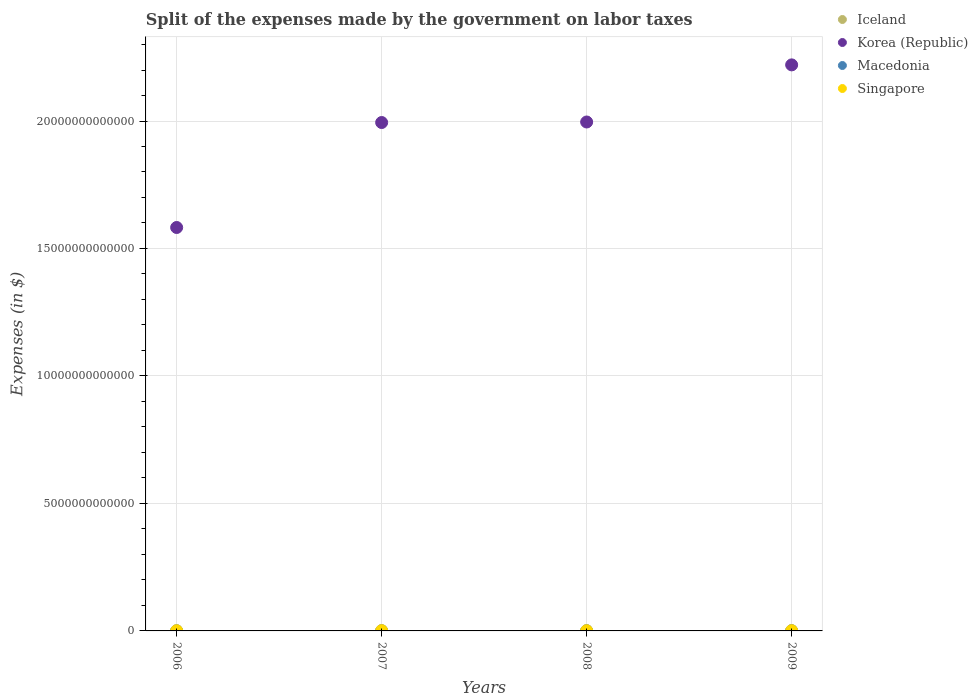How many different coloured dotlines are there?
Provide a succinct answer. 4. What is the expenses made by the government on labor taxes in Macedonia in 2006?
Ensure brevity in your answer.  6.58e+06. Across all years, what is the maximum expenses made by the government on labor taxes in Singapore?
Provide a succinct answer. 7.79e+09. Across all years, what is the minimum expenses made by the government on labor taxes in Singapore?
Provide a succinct answer. 5.35e+09. In which year was the expenses made by the government on labor taxes in Korea (Republic) minimum?
Your answer should be compact. 2006. What is the total expenses made by the government on labor taxes in Iceland in the graph?
Offer a terse response. 4.62e+1. What is the difference between the expenses made by the government on labor taxes in Iceland in 2006 and that in 2008?
Make the answer very short. -9.48e+08. What is the difference between the expenses made by the government on labor taxes in Macedonia in 2006 and the expenses made by the government on labor taxes in Singapore in 2007?
Offer a very short reply. -7.78e+09. What is the average expenses made by the government on labor taxes in Macedonia per year?
Give a very brief answer. 1.31e+09. In the year 2006, what is the difference between the expenses made by the government on labor taxes in Singapore and expenses made by the government on labor taxes in Korea (Republic)?
Ensure brevity in your answer.  -1.58e+13. What is the ratio of the expenses made by the government on labor taxes in Iceland in 2008 to that in 2009?
Your answer should be very brief. 0.86. Is the expenses made by the government on labor taxes in Singapore in 2008 less than that in 2009?
Provide a short and direct response. Yes. Is the difference between the expenses made by the government on labor taxes in Singapore in 2006 and 2009 greater than the difference between the expenses made by the government on labor taxes in Korea (Republic) in 2006 and 2009?
Offer a terse response. Yes. What is the difference between the highest and the second highest expenses made by the government on labor taxes in Macedonia?
Your answer should be compact. 1.15e+08. What is the difference between the highest and the lowest expenses made by the government on labor taxes in Iceland?
Your answer should be very brief. 3.82e+09. In how many years, is the expenses made by the government on labor taxes in Singapore greater than the average expenses made by the government on labor taxes in Singapore taken over all years?
Offer a very short reply. 2. Is the sum of the expenses made by the government on labor taxes in Iceland in 2007 and 2008 greater than the maximum expenses made by the government on labor taxes in Singapore across all years?
Your response must be concise. Yes. Is it the case that in every year, the sum of the expenses made by the government on labor taxes in Korea (Republic) and expenses made by the government on labor taxes in Iceland  is greater than the sum of expenses made by the government on labor taxes in Singapore and expenses made by the government on labor taxes in Macedonia?
Your response must be concise. No. Is it the case that in every year, the sum of the expenses made by the government on labor taxes in Korea (Republic) and expenses made by the government on labor taxes in Macedonia  is greater than the expenses made by the government on labor taxes in Singapore?
Ensure brevity in your answer.  Yes. Does the expenses made by the government on labor taxes in Macedonia monotonically increase over the years?
Offer a very short reply. Yes. Is the expenses made by the government on labor taxes in Iceland strictly less than the expenses made by the government on labor taxes in Korea (Republic) over the years?
Ensure brevity in your answer.  Yes. How many dotlines are there?
Offer a very short reply. 4. What is the difference between two consecutive major ticks on the Y-axis?
Your response must be concise. 5.00e+12. Are the values on the major ticks of Y-axis written in scientific E-notation?
Offer a terse response. No. Where does the legend appear in the graph?
Your answer should be very brief. Top right. How are the legend labels stacked?
Give a very brief answer. Vertical. What is the title of the graph?
Your answer should be very brief. Split of the expenses made by the government on labor taxes. Does "World" appear as one of the legend labels in the graph?
Your response must be concise. No. What is the label or title of the X-axis?
Provide a short and direct response. Years. What is the label or title of the Y-axis?
Ensure brevity in your answer.  Expenses (in $). What is the Expenses (in $) of Iceland in 2006?
Offer a terse response. 9.70e+09. What is the Expenses (in $) in Korea (Republic) in 2006?
Keep it short and to the point. 1.58e+13. What is the Expenses (in $) of Macedonia in 2006?
Give a very brief answer. 6.58e+06. What is the Expenses (in $) of Singapore in 2006?
Keep it short and to the point. 5.35e+09. What is the Expenses (in $) in Iceland in 2007?
Offer a terse response. 1.35e+1. What is the Expenses (in $) in Korea (Republic) in 2007?
Give a very brief answer. 1.99e+13. What is the Expenses (in $) in Macedonia in 2007?
Offer a very short reply. 6.93e+06. What is the Expenses (in $) in Singapore in 2007?
Your answer should be compact. 7.79e+09. What is the Expenses (in $) in Iceland in 2008?
Ensure brevity in your answer.  1.06e+1. What is the Expenses (in $) of Korea (Republic) in 2008?
Ensure brevity in your answer.  2.00e+13. What is the Expenses (in $) of Macedonia in 2008?
Your answer should be compact. 2.56e+09. What is the Expenses (in $) of Singapore in 2008?
Your answer should be very brief. 6.26e+09. What is the Expenses (in $) of Iceland in 2009?
Make the answer very short. 1.23e+1. What is the Expenses (in $) of Korea (Republic) in 2009?
Offer a terse response. 2.22e+13. What is the Expenses (in $) in Macedonia in 2009?
Keep it short and to the point. 2.68e+09. What is the Expenses (in $) of Singapore in 2009?
Keep it short and to the point. 6.78e+09. Across all years, what is the maximum Expenses (in $) of Iceland?
Provide a succinct answer. 1.35e+1. Across all years, what is the maximum Expenses (in $) in Korea (Republic)?
Provide a short and direct response. 2.22e+13. Across all years, what is the maximum Expenses (in $) of Macedonia?
Provide a short and direct response. 2.68e+09. Across all years, what is the maximum Expenses (in $) in Singapore?
Keep it short and to the point. 7.79e+09. Across all years, what is the minimum Expenses (in $) in Iceland?
Your response must be concise. 9.70e+09. Across all years, what is the minimum Expenses (in $) of Korea (Republic)?
Offer a terse response. 1.58e+13. Across all years, what is the minimum Expenses (in $) in Macedonia?
Offer a very short reply. 6.58e+06. Across all years, what is the minimum Expenses (in $) in Singapore?
Your response must be concise. 5.35e+09. What is the total Expenses (in $) in Iceland in the graph?
Your answer should be compact. 4.62e+1. What is the total Expenses (in $) in Korea (Republic) in the graph?
Make the answer very short. 7.79e+13. What is the total Expenses (in $) in Macedonia in the graph?
Your answer should be compact. 5.25e+09. What is the total Expenses (in $) in Singapore in the graph?
Your answer should be very brief. 2.62e+1. What is the difference between the Expenses (in $) in Iceland in 2006 and that in 2007?
Offer a very short reply. -3.82e+09. What is the difference between the Expenses (in $) of Korea (Republic) in 2006 and that in 2007?
Provide a succinct answer. -4.12e+12. What is the difference between the Expenses (in $) of Macedonia in 2006 and that in 2007?
Offer a terse response. -3.58e+05. What is the difference between the Expenses (in $) in Singapore in 2006 and that in 2007?
Provide a succinct answer. -2.44e+09. What is the difference between the Expenses (in $) in Iceland in 2006 and that in 2008?
Provide a short and direct response. -9.48e+08. What is the difference between the Expenses (in $) in Korea (Republic) in 2006 and that in 2008?
Give a very brief answer. -4.14e+12. What is the difference between the Expenses (in $) of Macedonia in 2006 and that in 2008?
Provide a short and direct response. -2.55e+09. What is the difference between the Expenses (in $) in Singapore in 2006 and that in 2008?
Your answer should be compact. -9.17e+08. What is the difference between the Expenses (in $) in Iceland in 2006 and that in 2009?
Offer a terse response. -2.65e+09. What is the difference between the Expenses (in $) of Korea (Republic) in 2006 and that in 2009?
Keep it short and to the point. -6.38e+12. What is the difference between the Expenses (in $) of Macedonia in 2006 and that in 2009?
Your answer should be compact. -2.67e+09. What is the difference between the Expenses (in $) of Singapore in 2006 and that in 2009?
Make the answer very short. -1.44e+09. What is the difference between the Expenses (in $) in Iceland in 2007 and that in 2008?
Your answer should be compact. 2.87e+09. What is the difference between the Expenses (in $) in Korea (Republic) in 2007 and that in 2008?
Make the answer very short. -2.06e+1. What is the difference between the Expenses (in $) of Macedonia in 2007 and that in 2008?
Make the answer very short. -2.55e+09. What is the difference between the Expenses (in $) in Singapore in 2007 and that in 2008?
Your answer should be very brief. 1.53e+09. What is the difference between the Expenses (in $) in Iceland in 2007 and that in 2009?
Keep it short and to the point. 1.18e+09. What is the difference between the Expenses (in $) of Korea (Republic) in 2007 and that in 2009?
Your answer should be compact. -2.26e+12. What is the difference between the Expenses (in $) of Macedonia in 2007 and that in 2009?
Your response must be concise. -2.67e+09. What is the difference between the Expenses (in $) of Singapore in 2007 and that in 2009?
Provide a short and direct response. 1.01e+09. What is the difference between the Expenses (in $) in Iceland in 2008 and that in 2009?
Your answer should be very brief. -1.70e+09. What is the difference between the Expenses (in $) of Korea (Republic) in 2008 and that in 2009?
Your answer should be very brief. -2.24e+12. What is the difference between the Expenses (in $) in Macedonia in 2008 and that in 2009?
Your response must be concise. -1.15e+08. What is the difference between the Expenses (in $) of Singapore in 2008 and that in 2009?
Offer a terse response. -5.19e+08. What is the difference between the Expenses (in $) of Iceland in 2006 and the Expenses (in $) of Korea (Republic) in 2007?
Ensure brevity in your answer.  -1.99e+13. What is the difference between the Expenses (in $) of Iceland in 2006 and the Expenses (in $) of Macedonia in 2007?
Make the answer very short. 9.69e+09. What is the difference between the Expenses (in $) of Iceland in 2006 and the Expenses (in $) of Singapore in 2007?
Your answer should be compact. 1.91e+09. What is the difference between the Expenses (in $) of Korea (Republic) in 2006 and the Expenses (in $) of Macedonia in 2007?
Your response must be concise. 1.58e+13. What is the difference between the Expenses (in $) in Korea (Republic) in 2006 and the Expenses (in $) in Singapore in 2007?
Offer a terse response. 1.58e+13. What is the difference between the Expenses (in $) of Macedonia in 2006 and the Expenses (in $) of Singapore in 2007?
Make the answer very short. -7.78e+09. What is the difference between the Expenses (in $) of Iceland in 2006 and the Expenses (in $) of Korea (Republic) in 2008?
Make the answer very short. -2.00e+13. What is the difference between the Expenses (in $) in Iceland in 2006 and the Expenses (in $) in Macedonia in 2008?
Your answer should be very brief. 7.14e+09. What is the difference between the Expenses (in $) in Iceland in 2006 and the Expenses (in $) in Singapore in 2008?
Your answer should be compact. 3.44e+09. What is the difference between the Expenses (in $) of Korea (Republic) in 2006 and the Expenses (in $) of Macedonia in 2008?
Keep it short and to the point. 1.58e+13. What is the difference between the Expenses (in $) of Korea (Republic) in 2006 and the Expenses (in $) of Singapore in 2008?
Give a very brief answer. 1.58e+13. What is the difference between the Expenses (in $) in Macedonia in 2006 and the Expenses (in $) in Singapore in 2008?
Provide a short and direct response. -6.26e+09. What is the difference between the Expenses (in $) in Iceland in 2006 and the Expenses (in $) in Korea (Republic) in 2009?
Make the answer very short. -2.22e+13. What is the difference between the Expenses (in $) of Iceland in 2006 and the Expenses (in $) of Macedonia in 2009?
Your answer should be compact. 7.03e+09. What is the difference between the Expenses (in $) of Iceland in 2006 and the Expenses (in $) of Singapore in 2009?
Provide a short and direct response. 2.92e+09. What is the difference between the Expenses (in $) in Korea (Republic) in 2006 and the Expenses (in $) in Macedonia in 2009?
Make the answer very short. 1.58e+13. What is the difference between the Expenses (in $) of Korea (Republic) in 2006 and the Expenses (in $) of Singapore in 2009?
Offer a very short reply. 1.58e+13. What is the difference between the Expenses (in $) of Macedonia in 2006 and the Expenses (in $) of Singapore in 2009?
Make the answer very short. -6.78e+09. What is the difference between the Expenses (in $) in Iceland in 2007 and the Expenses (in $) in Korea (Republic) in 2008?
Provide a short and direct response. -1.99e+13. What is the difference between the Expenses (in $) in Iceland in 2007 and the Expenses (in $) in Macedonia in 2008?
Provide a short and direct response. 1.10e+1. What is the difference between the Expenses (in $) in Iceland in 2007 and the Expenses (in $) in Singapore in 2008?
Your response must be concise. 7.26e+09. What is the difference between the Expenses (in $) of Korea (Republic) in 2007 and the Expenses (in $) of Macedonia in 2008?
Provide a succinct answer. 1.99e+13. What is the difference between the Expenses (in $) of Korea (Republic) in 2007 and the Expenses (in $) of Singapore in 2008?
Make the answer very short. 1.99e+13. What is the difference between the Expenses (in $) of Macedonia in 2007 and the Expenses (in $) of Singapore in 2008?
Make the answer very short. -6.26e+09. What is the difference between the Expenses (in $) in Iceland in 2007 and the Expenses (in $) in Korea (Republic) in 2009?
Give a very brief answer. -2.22e+13. What is the difference between the Expenses (in $) of Iceland in 2007 and the Expenses (in $) of Macedonia in 2009?
Offer a terse response. 1.08e+1. What is the difference between the Expenses (in $) in Iceland in 2007 and the Expenses (in $) in Singapore in 2009?
Offer a very short reply. 6.74e+09. What is the difference between the Expenses (in $) of Korea (Republic) in 2007 and the Expenses (in $) of Macedonia in 2009?
Your answer should be compact. 1.99e+13. What is the difference between the Expenses (in $) of Korea (Republic) in 2007 and the Expenses (in $) of Singapore in 2009?
Your answer should be compact. 1.99e+13. What is the difference between the Expenses (in $) in Macedonia in 2007 and the Expenses (in $) in Singapore in 2009?
Your response must be concise. -6.78e+09. What is the difference between the Expenses (in $) in Iceland in 2008 and the Expenses (in $) in Korea (Republic) in 2009?
Your answer should be compact. -2.22e+13. What is the difference between the Expenses (in $) of Iceland in 2008 and the Expenses (in $) of Macedonia in 2009?
Give a very brief answer. 7.97e+09. What is the difference between the Expenses (in $) in Iceland in 2008 and the Expenses (in $) in Singapore in 2009?
Your response must be concise. 3.87e+09. What is the difference between the Expenses (in $) in Korea (Republic) in 2008 and the Expenses (in $) in Macedonia in 2009?
Give a very brief answer. 2.00e+13. What is the difference between the Expenses (in $) of Korea (Republic) in 2008 and the Expenses (in $) of Singapore in 2009?
Provide a short and direct response. 2.00e+13. What is the difference between the Expenses (in $) in Macedonia in 2008 and the Expenses (in $) in Singapore in 2009?
Provide a short and direct response. -4.22e+09. What is the average Expenses (in $) in Iceland per year?
Make the answer very short. 1.16e+1. What is the average Expenses (in $) in Korea (Republic) per year?
Keep it short and to the point. 1.95e+13. What is the average Expenses (in $) of Macedonia per year?
Provide a succinct answer. 1.31e+09. What is the average Expenses (in $) in Singapore per year?
Keep it short and to the point. 6.55e+09. In the year 2006, what is the difference between the Expenses (in $) of Iceland and Expenses (in $) of Korea (Republic)?
Ensure brevity in your answer.  -1.58e+13. In the year 2006, what is the difference between the Expenses (in $) of Iceland and Expenses (in $) of Macedonia?
Your answer should be very brief. 9.70e+09. In the year 2006, what is the difference between the Expenses (in $) of Iceland and Expenses (in $) of Singapore?
Keep it short and to the point. 4.35e+09. In the year 2006, what is the difference between the Expenses (in $) of Korea (Republic) and Expenses (in $) of Macedonia?
Offer a very short reply. 1.58e+13. In the year 2006, what is the difference between the Expenses (in $) of Korea (Republic) and Expenses (in $) of Singapore?
Ensure brevity in your answer.  1.58e+13. In the year 2006, what is the difference between the Expenses (in $) in Macedonia and Expenses (in $) in Singapore?
Provide a short and direct response. -5.34e+09. In the year 2007, what is the difference between the Expenses (in $) in Iceland and Expenses (in $) in Korea (Republic)?
Your answer should be compact. -1.99e+13. In the year 2007, what is the difference between the Expenses (in $) of Iceland and Expenses (in $) of Macedonia?
Offer a terse response. 1.35e+1. In the year 2007, what is the difference between the Expenses (in $) in Iceland and Expenses (in $) in Singapore?
Your response must be concise. 5.73e+09. In the year 2007, what is the difference between the Expenses (in $) in Korea (Republic) and Expenses (in $) in Macedonia?
Offer a very short reply. 1.99e+13. In the year 2007, what is the difference between the Expenses (in $) in Korea (Republic) and Expenses (in $) in Singapore?
Give a very brief answer. 1.99e+13. In the year 2007, what is the difference between the Expenses (in $) of Macedonia and Expenses (in $) of Singapore?
Your response must be concise. -7.78e+09. In the year 2008, what is the difference between the Expenses (in $) of Iceland and Expenses (in $) of Korea (Republic)?
Provide a succinct answer. -2.00e+13. In the year 2008, what is the difference between the Expenses (in $) in Iceland and Expenses (in $) in Macedonia?
Provide a short and direct response. 8.09e+09. In the year 2008, what is the difference between the Expenses (in $) of Iceland and Expenses (in $) of Singapore?
Ensure brevity in your answer.  4.39e+09. In the year 2008, what is the difference between the Expenses (in $) in Korea (Republic) and Expenses (in $) in Macedonia?
Your response must be concise. 2.00e+13. In the year 2008, what is the difference between the Expenses (in $) in Korea (Republic) and Expenses (in $) in Singapore?
Give a very brief answer. 2.00e+13. In the year 2008, what is the difference between the Expenses (in $) in Macedonia and Expenses (in $) in Singapore?
Give a very brief answer. -3.70e+09. In the year 2009, what is the difference between the Expenses (in $) of Iceland and Expenses (in $) of Korea (Republic)?
Provide a short and direct response. -2.22e+13. In the year 2009, what is the difference between the Expenses (in $) of Iceland and Expenses (in $) of Macedonia?
Your response must be concise. 9.67e+09. In the year 2009, what is the difference between the Expenses (in $) in Iceland and Expenses (in $) in Singapore?
Give a very brief answer. 5.56e+09. In the year 2009, what is the difference between the Expenses (in $) in Korea (Republic) and Expenses (in $) in Macedonia?
Your answer should be very brief. 2.22e+13. In the year 2009, what is the difference between the Expenses (in $) in Korea (Republic) and Expenses (in $) in Singapore?
Your answer should be very brief. 2.22e+13. In the year 2009, what is the difference between the Expenses (in $) of Macedonia and Expenses (in $) of Singapore?
Offer a terse response. -4.11e+09. What is the ratio of the Expenses (in $) in Iceland in 2006 to that in 2007?
Ensure brevity in your answer.  0.72. What is the ratio of the Expenses (in $) of Korea (Republic) in 2006 to that in 2007?
Your answer should be compact. 0.79. What is the ratio of the Expenses (in $) in Macedonia in 2006 to that in 2007?
Your answer should be very brief. 0.95. What is the ratio of the Expenses (in $) of Singapore in 2006 to that in 2007?
Provide a succinct answer. 0.69. What is the ratio of the Expenses (in $) of Iceland in 2006 to that in 2008?
Give a very brief answer. 0.91. What is the ratio of the Expenses (in $) of Korea (Republic) in 2006 to that in 2008?
Give a very brief answer. 0.79. What is the ratio of the Expenses (in $) in Macedonia in 2006 to that in 2008?
Your response must be concise. 0. What is the ratio of the Expenses (in $) of Singapore in 2006 to that in 2008?
Your answer should be very brief. 0.85. What is the ratio of the Expenses (in $) of Iceland in 2006 to that in 2009?
Provide a succinct answer. 0.79. What is the ratio of the Expenses (in $) in Korea (Republic) in 2006 to that in 2009?
Provide a short and direct response. 0.71. What is the ratio of the Expenses (in $) in Macedonia in 2006 to that in 2009?
Your response must be concise. 0. What is the ratio of the Expenses (in $) of Singapore in 2006 to that in 2009?
Keep it short and to the point. 0.79. What is the ratio of the Expenses (in $) in Iceland in 2007 to that in 2008?
Give a very brief answer. 1.27. What is the ratio of the Expenses (in $) in Macedonia in 2007 to that in 2008?
Your answer should be compact. 0. What is the ratio of the Expenses (in $) of Singapore in 2007 to that in 2008?
Provide a succinct answer. 1.24. What is the ratio of the Expenses (in $) of Iceland in 2007 to that in 2009?
Ensure brevity in your answer.  1.1. What is the ratio of the Expenses (in $) in Korea (Republic) in 2007 to that in 2009?
Provide a short and direct response. 0.9. What is the ratio of the Expenses (in $) in Macedonia in 2007 to that in 2009?
Offer a terse response. 0. What is the ratio of the Expenses (in $) in Singapore in 2007 to that in 2009?
Make the answer very short. 1.15. What is the ratio of the Expenses (in $) of Iceland in 2008 to that in 2009?
Provide a succinct answer. 0.86. What is the ratio of the Expenses (in $) of Korea (Republic) in 2008 to that in 2009?
Make the answer very short. 0.9. What is the ratio of the Expenses (in $) in Macedonia in 2008 to that in 2009?
Your answer should be compact. 0.96. What is the ratio of the Expenses (in $) of Singapore in 2008 to that in 2009?
Keep it short and to the point. 0.92. What is the difference between the highest and the second highest Expenses (in $) in Iceland?
Ensure brevity in your answer.  1.18e+09. What is the difference between the highest and the second highest Expenses (in $) in Korea (Republic)?
Provide a short and direct response. 2.24e+12. What is the difference between the highest and the second highest Expenses (in $) of Macedonia?
Give a very brief answer. 1.15e+08. What is the difference between the highest and the second highest Expenses (in $) of Singapore?
Your answer should be compact. 1.01e+09. What is the difference between the highest and the lowest Expenses (in $) in Iceland?
Ensure brevity in your answer.  3.82e+09. What is the difference between the highest and the lowest Expenses (in $) in Korea (Republic)?
Ensure brevity in your answer.  6.38e+12. What is the difference between the highest and the lowest Expenses (in $) in Macedonia?
Give a very brief answer. 2.67e+09. What is the difference between the highest and the lowest Expenses (in $) of Singapore?
Your answer should be very brief. 2.44e+09. 